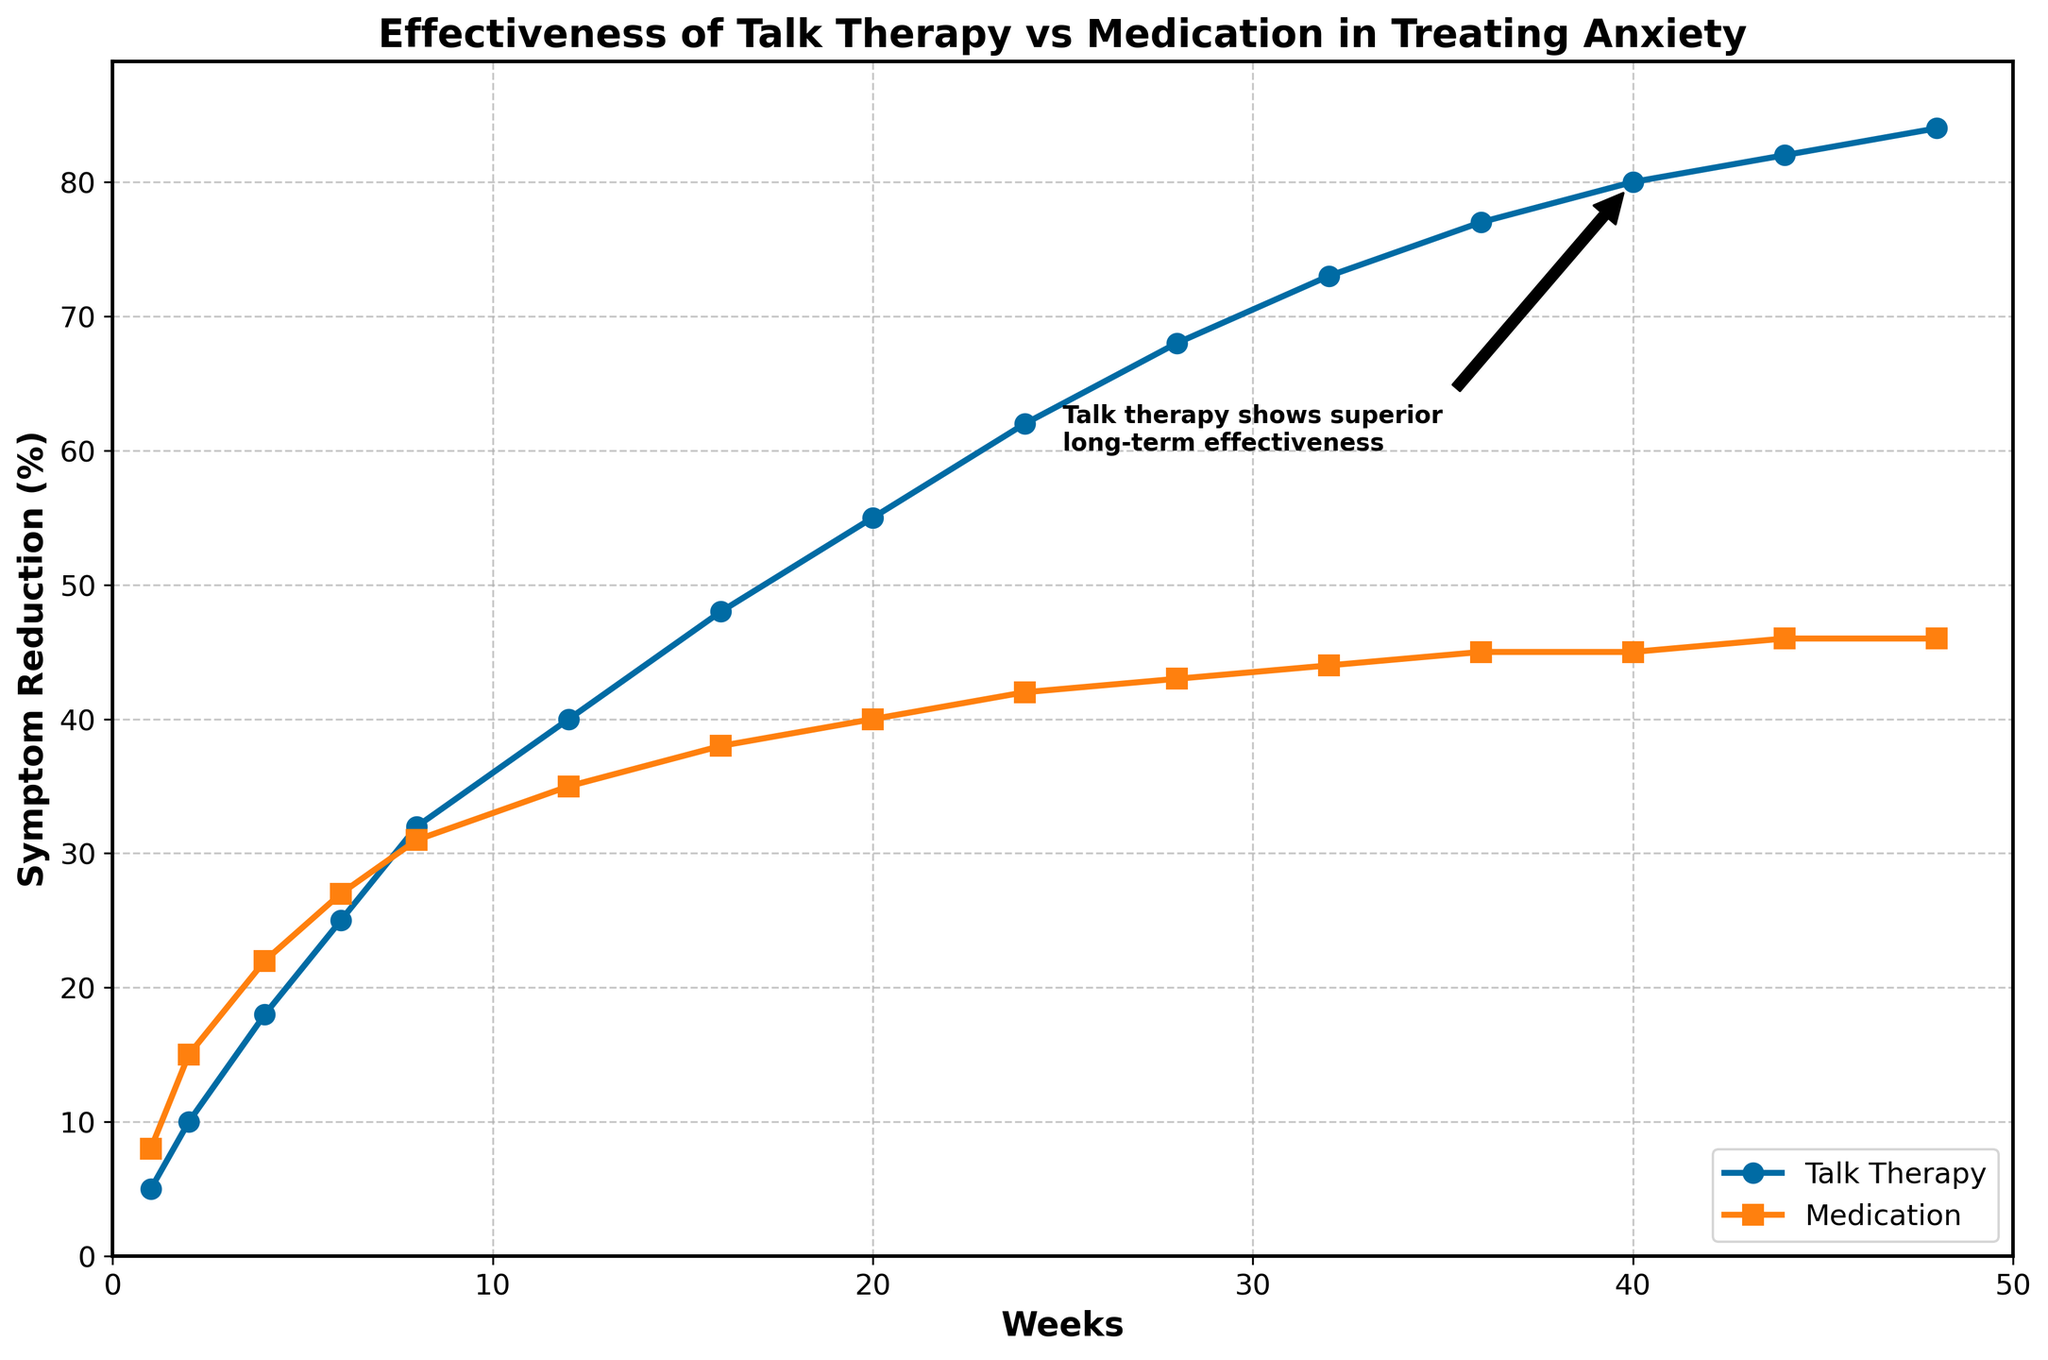What's the initial difference in symptom reduction between talk therapy and medication? In Week 1, talk therapy shows a symptom reduction of 5%, while medication shows 8%. The difference is 8% - 5% = 3%.
Answer: 3% At which week are the symptom reductions for both treatments closest? By looking at the overlaps of the two plots, Week 6 shows talk therapy symptom reduction at 25% and medication at 27%, which are the closest values.
Answer: Week 6 How much more effective is talk therapy compared to medication at Week 24? At Week 24, talk therapy shows a 62% reduction in symptoms, while medication shows 42%. The difference is 62% - 42% = 20%.
Answer: 20% What is the average symptom reduction over the first 12 weeks for talk therapy? Summing the weekly reductions for talk therapy at Weeks 1, 2, 4, 6, 8, and 12: (5 + 10 + 18 + 25 + 32 + 40) = 130%. The average is 130/6 = 21.67%.
Answer: 21.67% Which treatment reaches a 45% symptom reduction first? From the plots, Medication reaches 45% at Week 44, while talk therapy has not reached 45% by Week 44.
Answer: Medication What is the overall trend in symptom reduction for both treatments from Week 1 to Week 48? Both treatments show an increase in symptom reductions over time. However, talk therapy demonstrates a more consistent and steeper increase compared to medication.
Answer: Increasing At Week 48, what is the difference in symptom reduction between talk therapy and medication? At Week 48, talk therapy shows an 84% reduction in symptoms and medication shows 46%. The difference is 84% - 46% = 38%.
Answer: 38% When does talk therapy surpass medication in effectiveness by more than 10%? From the plot, by Week 12, talk therapy shows a 40% reduction, whereas medication shows 35%. Therefore, talk therapy surpasses medication by more than 10% by this week.
Answer: Week 12 Between Weeks 20 and 40, what is the increase in symptom reduction percentage for talk therapy? At Week 20, talk therapy shows 55% reduction and by Week 40, it shows 80%. The increase is 80% - 55% = 25%.
Answer: 25% How long does it take for talk therapy to achieve a 50% symptom reduction? From the plot, talk therapy achieves a 50% reduction around Week 20.
Answer: 20 weeks 